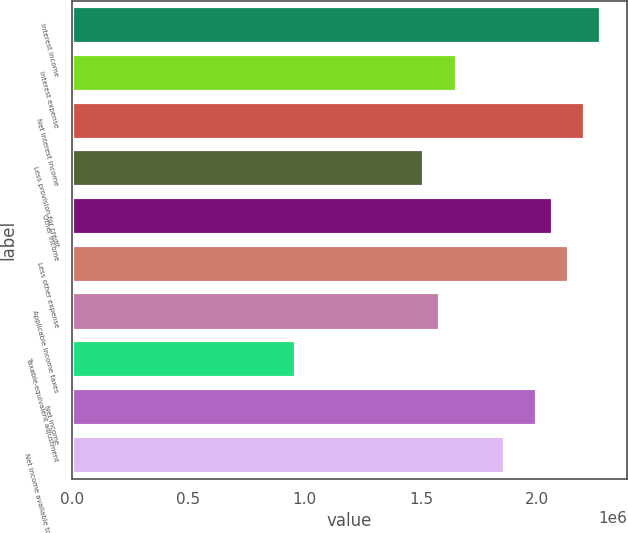<chart> <loc_0><loc_0><loc_500><loc_500><bar_chart><fcel>Interest income<fcel>Interest expense<fcel>Net interest income<fcel>Less provision for credit<fcel>Other income<fcel>Less other expense<fcel>Applicable income taxes<fcel>Taxable-equivalent adjustment<fcel>Net income<fcel>Net income available to common<nl><fcel>2.27322e+06<fcel>1.65325e+06<fcel>2.20433e+06<fcel>1.51548e+06<fcel>2.06656e+06<fcel>2.13545e+06<fcel>1.58437e+06<fcel>964397<fcel>1.99768e+06<fcel>1.85991e+06<nl></chart> 